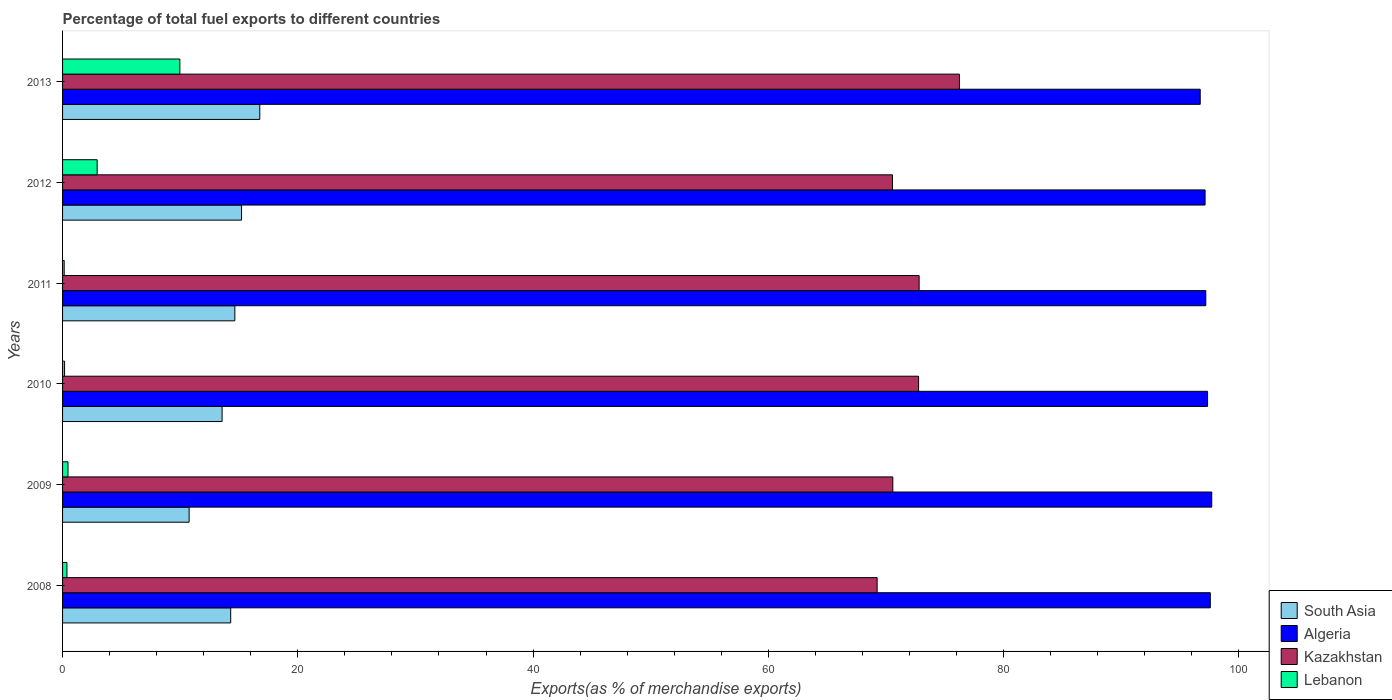How many different coloured bars are there?
Your answer should be compact. 4. How many groups of bars are there?
Ensure brevity in your answer.  6. How many bars are there on the 3rd tick from the top?
Make the answer very short. 4. How many bars are there on the 3rd tick from the bottom?
Keep it short and to the point. 4. What is the label of the 3rd group of bars from the top?
Ensure brevity in your answer.  2011. What is the percentage of exports to different countries in Kazakhstan in 2011?
Ensure brevity in your answer.  72.83. Across all years, what is the maximum percentage of exports to different countries in South Asia?
Give a very brief answer. 16.77. Across all years, what is the minimum percentage of exports to different countries in Kazakhstan?
Keep it short and to the point. 69.25. What is the total percentage of exports to different countries in South Asia in the graph?
Your answer should be very brief. 85.25. What is the difference between the percentage of exports to different countries in Lebanon in 2008 and that in 2012?
Your response must be concise. -2.57. What is the difference between the percentage of exports to different countries in Algeria in 2008 and the percentage of exports to different countries in South Asia in 2013?
Give a very brief answer. 80.81. What is the average percentage of exports to different countries in Lebanon per year?
Offer a very short reply. 2.34. In the year 2011, what is the difference between the percentage of exports to different countries in Kazakhstan and percentage of exports to different countries in South Asia?
Ensure brevity in your answer.  58.18. What is the ratio of the percentage of exports to different countries in South Asia in 2010 to that in 2012?
Provide a short and direct response. 0.89. Is the difference between the percentage of exports to different countries in Kazakhstan in 2009 and 2010 greater than the difference between the percentage of exports to different countries in South Asia in 2009 and 2010?
Give a very brief answer. Yes. What is the difference between the highest and the second highest percentage of exports to different countries in South Asia?
Give a very brief answer. 1.55. What is the difference between the highest and the lowest percentage of exports to different countries in Algeria?
Provide a short and direct response. 0.98. In how many years, is the percentage of exports to different countries in Kazakhstan greater than the average percentage of exports to different countries in Kazakhstan taken over all years?
Your answer should be very brief. 3. Is it the case that in every year, the sum of the percentage of exports to different countries in Kazakhstan and percentage of exports to different countries in South Asia is greater than the sum of percentage of exports to different countries in Algeria and percentage of exports to different countries in Lebanon?
Make the answer very short. Yes. What does the 3rd bar from the top in 2013 represents?
Offer a terse response. Algeria. What does the 1st bar from the bottom in 2013 represents?
Keep it short and to the point. South Asia. How many bars are there?
Give a very brief answer. 24. Are all the bars in the graph horizontal?
Your answer should be very brief. Yes. How many legend labels are there?
Ensure brevity in your answer.  4. What is the title of the graph?
Provide a succinct answer. Percentage of total fuel exports to different countries. What is the label or title of the X-axis?
Give a very brief answer. Exports(as % of merchandise exports). What is the label or title of the Y-axis?
Make the answer very short. Years. What is the Exports(as % of merchandise exports) of South Asia in 2008?
Keep it short and to the point. 14.29. What is the Exports(as % of merchandise exports) of Algeria in 2008?
Make the answer very short. 97.58. What is the Exports(as % of merchandise exports) in Kazakhstan in 2008?
Ensure brevity in your answer.  69.25. What is the Exports(as % of merchandise exports) of Lebanon in 2008?
Give a very brief answer. 0.37. What is the Exports(as % of merchandise exports) in South Asia in 2009?
Ensure brevity in your answer.  10.76. What is the Exports(as % of merchandise exports) of Algeria in 2009?
Provide a short and direct response. 97.7. What is the Exports(as % of merchandise exports) in Kazakhstan in 2009?
Provide a short and direct response. 70.59. What is the Exports(as % of merchandise exports) in Lebanon in 2009?
Make the answer very short. 0.46. What is the Exports(as % of merchandise exports) in South Asia in 2010?
Keep it short and to the point. 13.56. What is the Exports(as % of merchandise exports) in Algeria in 2010?
Ensure brevity in your answer.  97.35. What is the Exports(as % of merchandise exports) of Kazakhstan in 2010?
Your answer should be very brief. 72.78. What is the Exports(as % of merchandise exports) in Lebanon in 2010?
Your response must be concise. 0.17. What is the Exports(as % of merchandise exports) of South Asia in 2011?
Make the answer very short. 14.65. What is the Exports(as % of merchandise exports) in Algeria in 2011?
Offer a terse response. 97.2. What is the Exports(as % of merchandise exports) in Kazakhstan in 2011?
Make the answer very short. 72.83. What is the Exports(as % of merchandise exports) of Lebanon in 2011?
Offer a very short reply. 0.14. What is the Exports(as % of merchandise exports) in South Asia in 2012?
Your response must be concise. 15.22. What is the Exports(as % of merchandise exports) of Algeria in 2012?
Your answer should be compact. 97.14. What is the Exports(as % of merchandise exports) of Kazakhstan in 2012?
Make the answer very short. 70.56. What is the Exports(as % of merchandise exports) in Lebanon in 2012?
Give a very brief answer. 2.94. What is the Exports(as % of merchandise exports) in South Asia in 2013?
Ensure brevity in your answer.  16.77. What is the Exports(as % of merchandise exports) of Algeria in 2013?
Provide a succinct answer. 96.72. What is the Exports(as % of merchandise exports) in Kazakhstan in 2013?
Provide a short and direct response. 76.25. What is the Exports(as % of merchandise exports) in Lebanon in 2013?
Offer a terse response. 9.97. Across all years, what is the maximum Exports(as % of merchandise exports) of South Asia?
Provide a succinct answer. 16.77. Across all years, what is the maximum Exports(as % of merchandise exports) of Algeria?
Ensure brevity in your answer.  97.7. Across all years, what is the maximum Exports(as % of merchandise exports) of Kazakhstan?
Give a very brief answer. 76.25. Across all years, what is the maximum Exports(as % of merchandise exports) in Lebanon?
Your answer should be compact. 9.97. Across all years, what is the minimum Exports(as % of merchandise exports) in South Asia?
Provide a short and direct response. 10.76. Across all years, what is the minimum Exports(as % of merchandise exports) of Algeria?
Make the answer very short. 96.72. Across all years, what is the minimum Exports(as % of merchandise exports) of Kazakhstan?
Your answer should be very brief. 69.25. Across all years, what is the minimum Exports(as % of merchandise exports) in Lebanon?
Offer a very short reply. 0.14. What is the total Exports(as % of merchandise exports) of South Asia in the graph?
Ensure brevity in your answer.  85.25. What is the total Exports(as % of merchandise exports) in Algeria in the graph?
Your answer should be compact. 583.68. What is the total Exports(as % of merchandise exports) of Kazakhstan in the graph?
Your answer should be compact. 432.25. What is the total Exports(as % of merchandise exports) of Lebanon in the graph?
Make the answer very short. 14.06. What is the difference between the Exports(as % of merchandise exports) of South Asia in 2008 and that in 2009?
Offer a terse response. 3.54. What is the difference between the Exports(as % of merchandise exports) in Algeria in 2008 and that in 2009?
Your answer should be very brief. -0.12. What is the difference between the Exports(as % of merchandise exports) in Kazakhstan in 2008 and that in 2009?
Give a very brief answer. -1.33. What is the difference between the Exports(as % of merchandise exports) of Lebanon in 2008 and that in 2009?
Give a very brief answer. -0.09. What is the difference between the Exports(as % of merchandise exports) of South Asia in 2008 and that in 2010?
Offer a terse response. 0.73. What is the difference between the Exports(as % of merchandise exports) in Algeria in 2008 and that in 2010?
Offer a very short reply. 0.23. What is the difference between the Exports(as % of merchandise exports) in Kazakhstan in 2008 and that in 2010?
Offer a terse response. -3.52. What is the difference between the Exports(as % of merchandise exports) in Lebanon in 2008 and that in 2010?
Give a very brief answer. 0.2. What is the difference between the Exports(as % of merchandise exports) of South Asia in 2008 and that in 2011?
Offer a terse response. -0.35. What is the difference between the Exports(as % of merchandise exports) of Algeria in 2008 and that in 2011?
Provide a succinct answer. 0.38. What is the difference between the Exports(as % of merchandise exports) of Kazakhstan in 2008 and that in 2011?
Offer a very short reply. -3.57. What is the difference between the Exports(as % of merchandise exports) in Lebanon in 2008 and that in 2011?
Provide a succinct answer. 0.23. What is the difference between the Exports(as % of merchandise exports) in South Asia in 2008 and that in 2012?
Keep it short and to the point. -0.92. What is the difference between the Exports(as % of merchandise exports) of Algeria in 2008 and that in 2012?
Make the answer very short. 0.44. What is the difference between the Exports(as % of merchandise exports) of Kazakhstan in 2008 and that in 2012?
Provide a succinct answer. -1.3. What is the difference between the Exports(as % of merchandise exports) of Lebanon in 2008 and that in 2012?
Offer a very short reply. -2.57. What is the difference between the Exports(as % of merchandise exports) in South Asia in 2008 and that in 2013?
Offer a very short reply. -2.47. What is the difference between the Exports(as % of merchandise exports) in Algeria in 2008 and that in 2013?
Your answer should be compact. 0.86. What is the difference between the Exports(as % of merchandise exports) of Kazakhstan in 2008 and that in 2013?
Your answer should be compact. -6.99. What is the difference between the Exports(as % of merchandise exports) of Lebanon in 2008 and that in 2013?
Give a very brief answer. -9.6. What is the difference between the Exports(as % of merchandise exports) in South Asia in 2009 and that in 2010?
Your answer should be compact. -2.8. What is the difference between the Exports(as % of merchandise exports) in Algeria in 2009 and that in 2010?
Keep it short and to the point. 0.36. What is the difference between the Exports(as % of merchandise exports) in Kazakhstan in 2009 and that in 2010?
Offer a very short reply. -2.19. What is the difference between the Exports(as % of merchandise exports) of Lebanon in 2009 and that in 2010?
Ensure brevity in your answer.  0.29. What is the difference between the Exports(as % of merchandise exports) of South Asia in 2009 and that in 2011?
Your answer should be compact. -3.89. What is the difference between the Exports(as % of merchandise exports) in Algeria in 2009 and that in 2011?
Keep it short and to the point. 0.5. What is the difference between the Exports(as % of merchandise exports) in Kazakhstan in 2009 and that in 2011?
Give a very brief answer. -2.24. What is the difference between the Exports(as % of merchandise exports) of Lebanon in 2009 and that in 2011?
Your response must be concise. 0.32. What is the difference between the Exports(as % of merchandise exports) in South Asia in 2009 and that in 2012?
Your answer should be compact. -4.46. What is the difference between the Exports(as % of merchandise exports) in Algeria in 2009 and that in 2012?
Provide a short and direct response. 0.57. What is the difference between the Exports(as % of merchandise exports) of Kazakhstan in 2009 and that in 2012?
Keep it short and to the point. 0.03. What is the difference between the Exports(as % of merchandise exports) of Lebanon in 2009 and that in 2012?
Your answer should be compact. -2.48. What is the difference between the Exports(as % of merchandise exports) in South Asia in 2009 and that in 2013?
Provide a succinct answer. -6.01. What is the difference between the Exports(as % of merchandise exports) of Algeria in 2009 and that in 2013?
Offer a very short reply. 0.98. What is the difference between the Exports(as % of merchandise exports) of Kazakhstan in 2009 and that in 2013?
Your answer should be very brief. -5.66. What is the difference between the Exports(as % of merchandise exports) of Lebanon in 2009 and that in 2013?
Offer a terse response. -9.51. What is the difference between the Exports(as % of merchandise exports) in South Asia in 2010 and that in 2011?
Offer a terse response. -1.08. What is the difference between the Exports(as % of merchandise exports) of Algeria in 2010 and that in 2011?
Offer a very short reply. 0.15. What is the difference between the Exports(as % of merchandise exports) in Kazakhstan in 2010 and that in 2011?
Keep it short and to the point. -0.05. What is the difference between the Exports(as % of merchandise exports) of Lebanon in 2010 and that in 2011?
Offer a terse response. 0.03. What is the difference between the Exports(as % of merchandise exports) of South Asia in 2010 and that in 2012?
Offer a very short reply. -1.65. What is the difference between the Exports(as % of merchandise exports) in Algeria in 2010 and that in 2012?
Offer a terse response. 0.21. What is the difference between the Exports(as % of merchandise exports) of Kazakhstan in 2010 and that in 2012?
Your answer should be compact. 2.22. What is the difference between the Exports(as % of merchandise exports) in Lebanon in 2010 and that in 2012?
Make the answer very short. -2.77. What is the difference between the Exports(as % of merchandise exports) in South Asia in 2010 and that in 2013?
Your answer should be compact. -3.2. What is the difference between the Exports(as % of merchandise exports) in Algeria in 2010 and that in 2013?
Keep it short and to the point. 0.62. What is the difference between the Exports(as % of merchandise exports) in Kazakhstan in 2010 and that in 2013?
Your response must be concise. -3.47. What is the difference between the Exports(as % of merchandise exports) of Lebanon in 2010 and that in 2013?
Give a very brief answer. -9.8. What is the difference between the Exports(as % of merchandise exports) of South Asia in 2011 and that in 2012?
Your response must be concise. -0.57. What is the difference between the Exports(as % of merchandise exports) of Algeria in 2011 and that in 2012?
Provide a succinct answer. 0.06. What is the difference between the Exports(as % of merchandise exports) in Kazakhstan in 2011 and that in 2012?
Offer a terse response. 2.27. What is the difference between the Exports(as % of merchandise exports) of Lebanon in 2011 and that in 2012?
Your answer should be very brief. -2.8. What is the difference between the Exports(as % of merchandise exports) in South Asia in 2011 and that in 2013?
Your answer should be compact. -2.12. What is the difference between the Exports(as % of merchandise exports) of Algeria in 2011 and that in 2013?
Your response must be concise. 0.47. What is the difference between the Exports(as % of merchandise exports) in Kazakhstan in 2011 and that in 2013?
Give a very brief answer. -3.42. What is the difference between the Exports(as % of merchandise exports) in Lebanon in 2011 and that in 2013?
Ensure brevity in your answer.  -9.84. What is the difference between the Exports(as % of merchandise exports) in South Asia in 2012 and that in 2013?
Provide a succinct answer. -1.55. What is the difference between the Exports(as % of merchandise exports) in Algeria in 2012 and that in 2013?
Make the answer very short. 0.41. What is the difference between the Exports(as % of merchandise exports) in Kazakhstan in 2012 and that in 2013?
Make the answer very short. -5.69. What is the difference between the Exports(as % of merchandise exports) of Lebanon in 2012 and that in 2013?
Provide a succinct answer. -7.03. What is the difference between the Exports(as % of merchandise exports) of South Asia in 2008 and the Exports(as % of merchandise exports) of Algeria in 2009?
Give a very brief answer. -83.41. What is the difference between the Exports(as % of merchandise exports) of South Asia in 2008 and the Exports(as % of merchandise exports) of Kazakhstan in 2009?
Make the answer very short. -56.29. What is the difference between the Exports(as % of merchandise exports) of South Asia in 2008 and the Exports(as % of merchandise exports) of Lebanon in 2009?
Give a very brief answer. 13.83. What is the difference between the Exports(as % of merchandise exports) in Algeria in 2008 and the Exports(as % of merchandise exports) in Kazakhstan in 2009?
Make the answer very short. 26.99. What is the difference between the Exports(as % of merchandise exports) of Algeria in 2008 and the Exports(as % of merchandise exports) of Lebanon in 2009?
Keep it short and to the point. 97.12. What is the difference between the Exports(as % of merchandise exports) of Kazakhstan in 2008 and the Exports(as % of merchandise exports) of Lebanon in 2009?
Your response must be concise. 68.79. What is the difference between the Exports(as % of merchandise exports) in South Asia in 2008 and the Exports(as % of merchandise exports) in Algeria in 2010?
Your answer should be very brief. -83.05. What is the difference between the Exports(as % of merchandise exports) in South Asia in 2008 and the Exports(as % of merchandise exports) in Kazakhstan in 2010?
Make the answer very short. -58.48. What is the difference between the Exports(as % of merchandise exports) in South Asia in 2008 and the Exports(as % of merchandise exports) in Lebanon in 2010?
Keep it short and to the point. 14.12. What is the difference between the Exports(as % of merchandise exports) of Algeria in 2008 and the Exports(as % of merchandise exports) of Kazakhstan in 2010?
Give a very brief answer. 24.8. What is the difference between the Exports(as % of merchandise exports) in Algeria in 2008 and the Exports(as % of merchandise exports) in Lebanon in 2010?
Your answer should be very brief. 97.41. What is the difference between the Exports(as % of merchandise exports) in Kazakhstan in 2008 and the Exports(as % of merchandise exports) in Lebanon in 2010?
Keep it short and to the point. 69.08. What is the difference between the Exports(as % of merchandise exports) in South Asia in 2008 and the Exports(as % of merchandise exports) in Algeria in 2011?
Keep it short and to the point. -82.9. What is the difference between the Exports(as % of merchandise exports) of South Asia in 2008 and the Exports(as % of merchandise exports) of Kazakhstan in 2011?
Your answer should be compact. -58.53. What is the difference between the Exports(as % of merchandise exports) in South Asia in 2008 and the Exports(as % of merchandise exports) in Lebanon in 2011?
Your response must be concise. 14.16. What is the difference between the Exports(as % of merchandise exports) of Algeria in 2008 and the Exports(as % of merchandise exports) of Kazakhstan in 2011?
Give a very brief answer. 24.75. What is the difference between the Exports(as % of merchandise exports) of Algeria in 2008 and the Exports(as % of merchandise exports) of Lebanon in 2011?
Offer a terse response. 97.44. What is the difference between the Exports(as % of merchandise exports) in Kazakhstan in 2008 and the Exports(as % of merchandise exports) in Lebanon in 2011?
Your response must be concise. 69.12. What is the difference between the Exports(as % of merchandise exports) of South Asia in 2008 and the Exports(as % of merchandise exports) of Algeria in 2012?
Offer a very short reply. -82.84. What is the difference between the Exports(as % of merchandise exports) in South Asia in 2008 and the Exports(as % of merchandise exports) in Kazakhstan in 2012?
Your answer should be compact. -56.26. What is the difference between the Exports(as % of merchandise exports) of South Asia in 2008 and the Exports(as % of merchandise exports) of Lebanon in 2012?
Provide a succinct answer. 11.35. What is the difference between the Exports(as % of merchandise exports) in Algeria in 2008 and the Exports(as % of merchandise exports) in Kazakhstan in 2012?
Your response must be concise. 27.02. What is the difference between the Exports(as % of merchandise exports) of Algeria in 2008 and the Exports(as % of merchandise exports) of Lebanon in 2012?
Provide a short and direct response. 94.64. What is the difference between the Exports(as % of merchandise exports) in Kazakhstan in 2008 and the Exports(as % of merchandise exports) in Lebanon in 2012?
Offer a terse response. 66.31. What is the difference between the Exports(as % of merchandise exports) in South Asia in 2008 and the Exports(as % of merchandise exports) in Algeria in 2013?
Make the answer very short. -82.43. What is the difference between the Exports(as % of merchandise exports) of South Asia in 2008 and the Exports(as % of merchandise exports) of Kazakhstan in 2013?
Give a very brief answer. -61.95. What is the difference between the Exports(as % of merchandise exports) in South Asia in 2008 and the Exports(as % of merchandise exports) in Lebanon in 2013?
Give a very brief answer. 4.32. What is the difference between the Exports(as % of merchandise exports) of Algeria in 2008 and the Exports(as % of merchandise exports) of Kazakhstan in 2013?
Provide a short and direct response. 21.33. What is the difference between the Exports(as % of merchandise exports) in Algeria in 2008 and the Exports(as % of merchandise exports) in Lebanon in 2013?
Provide a short and direct response. 87.61. What is the difference between the Exports(as % of merchandise exports) in Kazakhstan in 2008 and the Exports(as % of merchandise exports) in Lebanon in 2013?
Give a very brief answer. 59.28. What is the difference between the Exports(as % of merchandise exports) in South Asia in 2009 and the Exports(as % of merchandise exports) in Algeria in 2010?
Offer a very short reply. -86.59. What is the difference between the Exports(as % of merchandise exports) in South Asia in 2009 and the Exports(as % of merchandise exports) in Kazakhstan in 2010?
Provide a succinct answer. -62.02. What is the difference between the Exports(as % of merchandise exports) of South Asia in 2009 and the Exports(as % of merchandise exports) of Lebanon in 2010?
Offer a very short reply. 10.59. What is the difference between the Exports(as % of merchandise exports) in Algeria in 2009 and the Exports(as % of merchandise exports) in Kazakhstan in 2010?
Keep it short and to the point. 24.92. What is the difference between the Exports(as % of merchandise exports) of Algeria in 2009 and the Exports(as % of merchandise exports) of Lebanon in 2010?
Offer a very short reply. 97.53. What is the difference between the Exports(as % of merchandise exports) of Kazakhstan in 2009 and the Exports(as % of merchandise exports) of Lebanon in 2010?
Provide a short and direct response. 70.42. What is the difference between the Exports(as % of merchandise exports) in South Asia in 2009 and the Exports(as % of merchandise exports) in Algeria in 2011?
Provide a succinct answer. -86.44. What is the difference between the Exports(as % of merchandise exports) of South Asia in 2009 and the Exports(as % of merchandise exports) of Kazakhstan in 2011?
Offer a terse response. -62.07. What is the difference between the Exports(as % of merchandise exports) of South Asia in 2009 and the Exports(as % of merchandise exports) of Lebanon in 2011?
Ensure brevity in your answer.  10.62. What is the difference between the Exports(as % of merchandise exports) in Algeria in 2009 and the Exports(as % of merchandise exports) in Kazakhstan in 2011?
Keep it short and to the point. 24.88. What is the difference between the Exports(as % of merchandise exports) in Algeria in 2009 and the Exports(as % of merchandise exports) in Lebanon in 2011?
Give a very brief answer. 97.56. What is the difference between the Exports(as % of merchandise exports) of Kazakhstan in 2009 and the Exports(as % of merchandise exports) of Lebanon in 2011?
Give a very brief answer. 70.45. What is the difference between the Exports(as % of merchandise exports) in South Asia in 2009 and the Exports(as % of merchandise exports) in Algeria in 2012?
Your answer should be compact. -86.38. What is the difference between the Exports(as % of merchandise exports) in South Asia in 2009 and the Exports(as % of merchandise exports) in Kazakhstan in 2012?
Give a very brief answer. -59.8. What is the difference between the Exports(as % of merchandise exports) in South Asia in 2009 and the Exports(as % of merchandise exports) in Lebanon in 2012?
Your response must be concise. 7.82. What is the difference between the Exports(as % of merchandise exports) in Algeria in 2009 and the Exports(as % of merchandise exports) in Kazakhstan in 2012?
Ensure brevity in your answer.  27.14. What is the difference between the Exports(as % of merchandise exports) in Algeria in 2009 and the Exports(as % of merchandise exports) in Lebanon in 2012?
Keep it short and to the point. 94.76. What is the difference between the Exports(as % of merchandise exports) of Kazakhstan in 2009 and the Exports(as % of merchandise exports) of Lebanon in 2012?
Provide a succinct answer. 67.65. What is the difference between the Exports(as % of merchandise exports) of South Asia in 2009 and the Exports(as % of merchandise exports) of Algeria in 2013?
Offer a very short reply. -85.96. What is the difference between the Exports(as % of merchandise exports) of South Asia in 2009 and the Exports(as % of merchandise exports) of Kazakhstan in 2013?
Keep it short and to the point. -65.49. What is the difference between the Exports(as % of merchandise exports) of South Asia in 2009 and the Exports(as % of merchandise exports) of Lebanon in 2013?
Make the answer very short. 0.79. What is the difference between the Exports(as % of merchandise exports) of Algeria in 2009 and the Exports(as % of merchandise exports) of Kazakhstan in 2013?
Offer a very short reply. 21.45. What is the difference between the Exports(as % of merchandise exports) of Algeria in 2009 and the Exports(as % of merchandise exports) of Lebanon in 2013?
Make the answer very short. 87.73. What is the difference between the Exports(as % of merchandise exports) in Kazakhstan in 2009 and the Exports(as % of merchandise exports) in Lebanon in 2013?
Your answer should be compact. 60.61. What is the difference between the Exports(as % of merchandise exports) in South Asia in 2010 and the Exports(as % of merchandise exports) in Algeria in 2011?
Offer a very short reply. -83.63. What is the difference between the Exports(as % of merchandise exports) in South Asia in 2010 and the Exports(as % of merchandise exports) in Kazakhstan in 2011?
Ensure brevity in your answer.  -59.26. What is the difference between the Exports(as % of merchandise exports) of South Asia in 2010 and the Exports(as % of merchandise exports) of Lebanon in 2011?
Your response must be concise. 13.43. What is the difference between the Exports(as % of merchandise exports) of Algeria in 2010 and the Exports(as % of merchandise exports) of Kazakhstan in 2011?
Offer a very short reply. 24.52. What is the difference between the Exports(as % of merchandise exports) in Algeria in 2010 and the Exports(as % of merchandise exports) in Lebanon in 2011?
Offer a terse response. 97.21. What is the difference between the Exports(as % of merchandise exports) in Kazakhstan in 2010 and the Exports(as % of merchandise exports) in Lebanon in 2011?
Your answer should be very brief. 72.64. What is the difference between the Exports(as % of merchandise exports) of South Asia in 2010 and the Exports(as % of merchandise exports) of Algeria in 2012?
Your response must be concise. -83.57. What is the difference between the Exports(as % of merchandise exports) in South Asia in 2010 and the Exports(as % of merchandise exports) in Kazakhstan in 2012?
Keep it short and to the point. -57. What is the difference between the Exports(as % of merchandise exports) of South Asia in 2010 and the Exports(as % of merchandise exports) of Lebanon in 2012?
Offer a very short reply. 10.62. What is the difference between the Exports(as % of merchandise exports) in Algeria in 2010 and the Exports(as % of merchandise exports) in Kazakhstan in 2012?
Your answer should be very brief. 26.79. What is the difference between the Exports(as % of merchandise exports) of Algeria in 2010 and the Exports(as % of merchandise exports) of Lebanon in 2012?
Provide a succinct answer. 94.4. What is the difference between the Exports(as % of merchandise exports) of Kazakhstan in 2010 and the Exports(as % of merchandise exports) of Lebanon in 2012?
Your answer should be very brief. 69.84. What is the difference between the Exports(as % of merchandise exports) of South Asia in 2010 and the Exports(as % of merchandise exports) of Algeria in 2013?
Give a very brief answer. -83.16. What is the difference between the Exports(as % of merchandise exports) of South Asia in 2010 and the Exports(as % of merchandise exports) of Kazakhstan in 2013?
Provide a short and direct response. -62.69. What is the difference between the Exports(as % of merchandise exports) in South Asia in 2010 and the Exports(as % of merchandise exports) in Lebanon in 2013?
Keep it short and to the point. 3.59. What is the difference between the Exports(as % of merchandise exports) in Algeria in 2010 and the Exports(as % of merchandise exports) in Kazakhstan in 2013?
Provide a succinct answer. 21.1. What is the difference between the Exports(as % of merchandise exports) of Algeria in 2010 and the Exports(as % of merchandise exports) of Lebanon in 2013?
Provide a short and direct response. 87.37. What is the difference between the Exports(as % of merchandise exports) of Kazakhstan in 2010 and the Exports(as % of merchandise exports) of Lebanon in 2013?
Provide a succinct answer. 62.8. What is the difference between the Exports(as % of merchandise exports) in South Asia in 2011 and the Exports(as % of merchandise exports) in Algeria in 2012?
Provide a short and direct response. -82.49. What is the difference between the Exports(as % of merchandise exports) of South Asia in 2011 and the Exports(as % of merchandise exports) of Kazakhstan in 2012?
Offer a very short reply. -55.91. What is the difference between the Exports(as % of merchandise exports) in South Asia in 2011 and the Exports(as % of merchandise exports) in Lebanon in 2012?
Keep it short and to the point. 11.71. What is the difference between the Exports(as % of merchandise exports) in Algeria in 2011 and the Exports(as % of merchandise exports) in Kazakhstan in 2012?
Provide a short and direct response. 26.64. What is the difference between the Exports(as % of merchandise exports) of Algeria in 2011 and the Exports(as % of merchandise exports) of Lebanon in 2012?
Offer a very short reply. 94.26. What is the difference between the Exports(as % of merchandise exports) in Kazakhstan in 2011 and the Exports(as % of merchandise exports) in Lebanon in 2012?
Your answer should be very brief. 69.88. What is the difference between the Exports(as % of merchandise exports) in South Asia in 2011 and the Exports(as % of merchandise exports) in Algeria in 2013?
Ensure brevity in your answer.  -82.07. What is the difference between the Exports(as % of merchandise exports) of South Asia in 2011 and the Exports(as % of merchandise exports) of Kazakhstan in 2013?
Offer a terse response. -61.6. What is the difference between the Exports(as % of merchandise exports) in South Asia in 2011 and the Exports(as % of merchandise exports) in Lebanon in 2013?
Your answer should be very brief. 4.67. What is the difference between the Exports(as % of merchandise exports) of Algeria in 2011 and the Exports(as % of merchandise exports) of Kazakhstan in 2013?
Ensure brevity in your answer.  20.95. What is the difference between the Exports(as % of merchandise exports) of Algeria in 2011 and the Exports(as % of merchandise exports) of Lebanon in 2013?
Your answer should be compact. 87.22. What is the difference between the Exports(as % of merchandise exports) of Kazakhstan in 2011 and the Exports(as % of merchandise exports) of Lebanon in 2013?
Provide a short and direct response. 62.85. What is the difference between the Exports(as % of merchandise exports) of South Asia in 2012 and the Exports(as % of merchandise exports) of Algeria in 2013?
Your answer should be compact. -81.5. What is the difference between the Exports(as % of merchandise exports) in South Asia in 2012 and the Exports(as % of merchandise exports) in Kazakhstan in 2013?
Your answer should be very brief. -61.03. What is the difference between the Exports(as % of merchandise exports) of South Asia in 2012 and the Exports(as % of merchandise exports) of Lebanon in 2013?
Your answer should be compact. 5.24. What is the difference between the Exports(as % of merchandise exports) of Algeria in 2012 and the Exports(as % of merchandise exports) of Kazakhstan in 2013?
Ensure brevity in your answer.  20.89. What is the difference between the Exports(as % of merchandise exports) in Algeria in 2012 and the Exports(as % of merchandise exports) in Lebanon in 2013?
Ensure brevity in your answer.  87.16. What is the difference between the Exports(as % of merchandise exports) in Kazakhstan in 2012 and the Exports(as % of merchandise exports) in Lebanon in 2013?
Provide a succinct answer. 60.59. What is the average Exports(as % of merchandise exports) of South Asia per year?
Your response must be concise. 14.21. What is the average Exports(as % of merchandise exports) in Algeria per year?
Provide a short and direct response. 97.28. What is the average Exports(as % of merchandise exports) in Kazakhstan per year?
Your answer should be compact. 72.04. What is the average Exports(as % of merchandise exports) in Lebanon per year?
Your answer should be compact. 2.34. In the year 2008, what is the difference between the Exports(as % of merchandise exports) in South Asia and Exports(as % of merchandise exports) in Algeria?
Keep it short and to the point. -83.28. In the year 2008, what is the difference between the Exports(as % of merchandise exports) in South Asia and Exports(as % of merchandise exports) in Kazakhstan?
Offer a very short reply. -54.96. In the year 2008, what is the difference between the Exports(as % of merchandise exports) in South Asia and Exports(as % of merchandise exports) in Lebanon?
Keep it short and to the point. 13.92. In the year 2008, what is the difference between the Exports(as % of merchandise exports) of Algeria and Exports(as % of merchandise exports) of Kazakhstan?
Provide a succinct answer. 28.32. In the year 2008, what is the difference between the Exports(as % of merchandise exports) in Algeria and Exports(as % of merchandise exports) in Lebanon?
Provide a succinct answer. 97.21. In the year 2008, what is the difference between the Exports(as % of merchandise exports) of Kazakhstan and Exports(as % of merchandise exports) of Lebanon?
Keep it short and to the point. 68.88. In the year 2009, what is the difference between the Exports(as % of merchandise exports) of South Asia and Exports(as % of merchandise exports) of Algeria?
Your answer should be very brief. -86.94. In the year 2009, what is the difference between the Exports(as % of merchandise exports) in South Asia and Exports(as % of merchandise exports) in Kazakhstan?
Keep it short and to the point. -59.83. In the year 2009, what is the difference between the Exports(as % of merchandise exports) in South Asia and Exports(as % of merchandise exports) in Lebanon?
Offer a terse response. 10.3. In the year 2009, what is the difference between the Exports(as % of merchandise exports) of Algeria and Exports(as % of merchandise exports) of Kazakhstan?
Keep it short and to the point. 27.11. In the year 2009, what is the difference between the Exports(as % of merchandise exports) of Algeria and Exports(as % of merchandise exports) of Lebanon?
Offer a terse response. 97.24. In the year 2009, what is the difference between the Exports(as % of merchandise exports) of Kazakhstan and Exports(as % of merchandise exports) of Lebanon?
Keep it short and to the point. 70.13. In the year 2010, what is the difference between the Exports(as % of merchandise exports) of South Asia and Exports(as % of merchandise exports) of Algeria?
Your answer should be compact. -83.78. In the year 2010, what is the difference between the Exports(as % of merchandise exports) in South Asia and Exports(as % of merchandise exports) in Kazakhstan?
Ensure brevity in your answer.  -59.21. In the year 2010, what is the difference between the Exports(as % of merchandise exports) of South Asia and Exports(as % of merchandise exports) of Lebanon?
Give a very brief answer. 13.39. In the year 2010, what is the difference between the Exports(as % of merchandise exports) in Algeria and Exports(as % of merchandise exports) in Kazakhstan?
Provide a short and direct response. 24.57. In the year 2010, what is the difference between the Exports(as % of merchandise exports) of Algeria and Exports(as % of merchandise exports) of Lebanon?
Your answer should be compact. 97.18. In the year 2010, what is the difference between the Exports(as % of merchandise exports) in Kazakhstan and Exports(as % of merchandise exports) in Lebanon?
Ensure brevity in your answer.  72.61. In the year 2011, what is the difference between the Exports(as % of merchandise exports) in South Asia and Exports(as % of merchandise exports) in Algeria?
Provide a short and direct response. -82.55. In the year 2011, what is the difference between the Exports(as % of merchandise exports) in South Asia and Exports(as % of merchandise exports) in Kazakhstan?
Keep it short and to the point. -58.18. In the year 2011, what is the difference between the Exports(as % of merchandise exports) of South Asia and Exports(as % of merchandise exports) of Lebanon?
Make the answer very short. 14.51. In the year 2011, what is the difference between the Exports(as % of merchandise exports) in Algeria and Exports(as % of merchandise exports) in Kazakhstan?
Your answer should be very brief. 24.37. In the year 2011, what is the difference between the Exports(as % of merchandise exports) of Algeria and Exports(as % of merchandise exports) of Lebanon?
Keep it short and to the point. 97.06. In the year 2011, what is the difference between the Exports(as % of merchandise exports) of Kazakhstan and Exports(as % of merchandise exports) of Lebanon?
Make the answer very short. 72.69. In the year 2012, what is the difference between the Exports(as % of merchandise exports) in South Asia and Exports(as % of merchandise exports) in Algeria?
Offer a terse response. -81.92. In the year 2012, what is the difference between the Exports(as % of merchandise exports) of South Asia and Exports(as % of merchandise exports) of Kazakhstan?
Your answer should be compact. -55.34. In the year 2012, what is the difference between the Exports(as % of merchandise exports) of South Asia and Exports(as % of merchandise exports) of Lebanon?
Offer a terse response. 12.28. In the year 2012, what is the difference between the Exports(as % of merchandise exports) of Algeria and Exports(as % of merchandise exports) of Kazakhstan?
Keep it short and to the point. 26.58. In the year 2012, what is the difference between the Exports(as % of merchandise exports) of Algeria and Exports(as % of merchandise exports) of Lebanon?
Make the answer very short. 94.19. In the year 2012, what is the difference between the Exports(as % of merchandise exports) in Kazakhstan and Exports(as % of merchandise exports) in Lebanon?
Provide a short and direct response. 67.62. In the year 2013, what is the difference between the Exports(as % of merchandise exports) in South Asia and Exports(as % of merchandise exports) in Algeria?
Provide a short and direct response. -79.96. In the year 2013, what is the difference between the Exports(as % of merchandise exports) of South Asia and Exports(as % of merchandise exports) of Kazakhstan?
Give a very brief answer. -59.48. In the year 2013, what is the difference between the Exports(as % of merchandise exports) of South Asia and Exports(as % of merchandise exports) of Lebanon?
Offer a terse response. 6.79. In the year 2013, what is the difference between the Exports(as % of merchandise exports) of Algeria and Exports(as % of merchandise exports) of Kazakhstan?
Give a very brief answer. 20.47. In the year 2013, what is the difference between the Exports(as % of merchandise exports) in Algeria and Exports(as % of merchandise exports) in Lebanon?
Your answer should be very brief. 86.75. In the year 2013, what is the difference between the Exports(as % of merchandise exports) in Kazakhstan and Exports(as % of merchandise exports) in Lebanon?
Your response must be concise. 66.28. What is the ratio of the Exports(as % of merchandise exports) in South Asia in 2008 to that in 2009?
Your response must be concise. 1.33. What is the ratio of the Exports(as % of merchandise exports) of Algeria in 2008 to that in 2009?
Offer a very short reply. 1. What is the ratio of the Exports(as % of merchandise exports) of Kazakhstan in 2008 to that in 2009?
Your response must be concise. 0.98. What is the ratio of the Exports(as % of merchandise exports) of Lebanon in 2008 to that in 2009?
Offer a very short reply. 0.81. What is the ratio of the Exports(as % of merchandise exports) of South Asia in 2008 to that in 2010?
Ensure brevity in your answer.  1.05. What is the ratio of the Exports(as % of merchandise exports) of Algeria in 2008 to that in 2010?
Offer a terse response. 1. What is the ratio of the Exports(as % of merchandise exports) in Kazakhstan in 2008 to that in 2010?
Give a very brief answer. 0.95. What is the ratio of the Exports(as % of merchandise exports) of Lebanon in 2008 to that in 2010?
Give a very brief answer. 2.18. What is the ratio of the Exports(as % of merchandise exports) of South Asia in 2008 to that in 2011?
Offer a terse response. 0.98. What is the ratio of the Exports(as % of merchandise exports) in Algeria in 2008 to that in 2011?
Your response must be concise. 1. What is the ratio of the Exports(as % of merchandise exports) in Kazakhstan in 2008 to that in 2011?
Make the answer very short. 0.95. What is the ratio of the Exports(as % of merchandise exports) of Lebanon in 2008 to that in 2011?
Ensure brevity in your answer.  2.69. What is the ratio of the Exports(as % of merchandise exports) in South Asia in 2008 to that in 2012?
Keep it short and to the point. 0.94. What is the ratio of the Exports(as % of merchandise exports) of Algeria in 2008 to that in 2012?
Your answer should be very brief. 1. What is the ratio of the Exports(as % of merchandise exports) of Kazakhstan in 2008 to that in 2012?
Your answer should be compact. 0.98. What is the ratio of the Exports(as % of merchandise exports) of Lebanon in 2008 to that in 2012?
Your answer should be very brief. 0.13. What is the ratio of the Exports(as % of merchandise exports) in South Asia in 2008 to that in 2013?
Offer a very short reply. 0.85. What is the ratio of the Exports(as % of merchandise exports) in Algeria in 2008 to that in 2013?
Ensure brevity in your answer.  1.01. What is the ratio of the Exports(as % of merchandise exports) in Kazakhstan in 2008 to that in 2013?
Your answer should be very brief. 0.91. What is the ratio of the Exports(as % of merchandise exports) in Lebanon in 2008 to that in 2013?
Make the answer very short. 0.04. What is the ratio of the Exports(as % of merchandise exports) in South Asia in 2009 to that in 2010?
Give a very brief answer. 0.79. What is the ratio of the Exports(as % of merchandise exports) of Algeria in 2009 to that in 2010?
Offer a terse response. 1. What is the ratio of the Exports(as % of merchandise exports) in Kazakhstan in 2009 to that in 2010?
Provide a short and direct response. 0.97. What is the ratio of the Exports(as % of merchandise exports) of Lebanon in 2009 to that in 2010?
Keep it short and to the point. 2.71. What is the ratio of the Exports(as % of merchandise exports) of South Asia in 2009 to that in 2011?
Ensure brevity in your answer.  0.73. What is the ratio of the Exports(as % of merchandise exports) in Algeria in 2009 to that in 2011?
Ensure brevity in your answer.  1.01. What is the ratio of the Exports(as % of merchandise exports) in Kazakhstan in 2009 to that in 2011?
Make the answer very short. 0.97. What is the ratio of the Exports(as % of merchandise exports) of Lebanon in 2009 to that in 2011?
Your response must be concise. 3.34. What is the ratio of the Exports(as % of merchandise exports) of South Asia in 2009 to that in 2012?
Your response must be concise. 0.71. What is the ratio of the Exports(as % of merchandise exports) of Kazakhstan in 2009 to that in 2012?
Offer a terse response. 1. What is the ratio of the Exports(as % of merchandise exports) in Lebanon in 2009 to that in 2012?
Your response must be concise. 0.16. What is the ratio of the Exports(as % of merchandise exports) of South Asia in 2009 to that in 2013?
Make the answer very short. 0.64. What is the ratio of the Exports(as % of merchandise exports) of Algeria in 2009 to that in 2013?
Your answer should be very brief. 1.01. What is the ratio of the Exports(as % of merchandise exports) in Kazakhstan in 2009 to that in 2013?
Your answer should be very brief. 0.93. What is the ratio of the Exports(as % of merchandise exports) in Lebanon in 2009 to that in 2013?
Keep it short and to the point. 0.05. What is the ratio of the Exports(as % of merchandise exports) of South Asia in 2010 to that in 2011?
Ensure brevity in your answer.  0.93. What is the ratio of the Exports(as % of merchandise exports) of Lebanon in 2010 to that in 2011?
Your response must be concise. 1.23. What is the ratio of the Exports(as % of merchandise exports) of South Asia in 2010 to that in 2012?
Provide a succinct answer. 0.89. What is the ratio of the Exports(as % of merchandise exports) in Algeria in 2010 to that in 2012?
Provide a short and direct response. 1. What is the ratio of the Exports(as % of merchandise exports) of Kazakhstan in 2010 to that in 2012?
Offer a terse response. 1.03. What is the ratio of the Exports(as % of merchandise exports) of Lebanon in 2010 to that in 2012?
Your response must be concise. 0.06. What is the ratio of the Exports(as % of merchandise exports) of South Asia in 2010 to that in 2013?
Your answer should be compact. 0.81. What is the ratio of the Exports(as % of merchandise exports) in Kazakhstan in 2010 to that in 2013?
Your answer should be very brief. 0.95. What is the ratio of the Exports(as % of merchandise exports) in Lebanon in 2010 to that in 2013?
Make the answer very short. 0.02. What is the ratio of the Exports(as % of merchandise exports) in South Asia in 2011 to that in 2012?
Your response must be concise. 0.96. What is the ratio of the Exports(as % of merchandise exports) of Kazakhstan in 2011 to that in 2012?
Your response must be concise. 1.03. What is the ratio of the Exports(as % of merchandise exports) in Lebanon in 2011 to that in 2012?
Keep it short and to the point. 0.05. What is the ratio of the Exports(as % of merchandise exports) of South Asia in 2011 to that in 2013?
Provide a succinct answer. 0.87. What is the ratio of the Exports(as % of merchandise exports) of Kazakhstan in 2011 to that in 2013?
Offer a very short reply. 0.96. What is the ratio of the Exports(as % of merchandise exports) of Lebanon in 2011 to that in 2013?
Provide a short and direct response. 0.01. What is the ratio of the Exports(as % of merchandise exports) of South Asia in 2012 to that in 2013?
Make the answer very short. 0.91. What is the ratio of the Exports(as % of merchandise exports) in Kazakhstan in 2012 to that in 2013?
Offer a terse response. 0.93. What is the ratio of the Exports(as % of merchandise exports) in Lebanon in 2012 to that in 2013?
Make the answer very short. 0.29. What is the difference between the highest and the second highest Exports(as % of merchandise exports) in South Asia?
Your response must be concise. 1.55. What is the difference between the highest and the second highest Exports(as % of merchandise exports) in Algeria?
Provide a short and direct response. 0.12. What is the difference between the highest and the second highest Exports(as % of merchandise exports) of Kazakhstan?
Offer a very short reply. 3.42. What is the difference between the highest and the second highest Exports(as % of merchandise exports) in Lebanon?
Your response must be concise. 7.03. What is the difference between the highest and the lowest Exports(as % of merchandise exports) of South Asia?
Your answer should be compact. 6.01. What is the difference between the highest and the lowest Exports(as % of merchandise exports) in Algeria?
Your response must be concise. 0.98. What is the difference between the highest and the lowest Exports(as % of merchandise exports) of Kazakhstan?
Keep it short and to the point. 6.99. What is the difference between the highest and the lowest Exports(as % of merchandise exports) in Lebanon?
Offer a terse response. 9.84. 